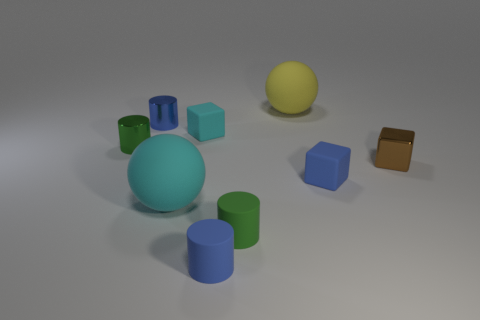Is the color of the matte sphere that is to the left of the large yellow object the same as the small rubber cube behind the small brown thing?
Your answer should be compact. Yes. There is a small thing that is both left of the blue rubber cylinder and on the right side of the tiny blue shiny cylinder; what is it made of?
Provide a succinct answer. Rubber. Is there a large shiny cylinder?
Ensure brevity in your answer.  No. The small cyan thing that is the same material as the small blue block is what shape?
Offer a very short reply. Cube. There is a blue metal thing; is its shape the same as the big matte object that is behind the cyan matte sphere?
Ensure brevity in your answer.  No. What material is the green cylinder behind the small block in front of the brown object?
Your answer should be compact. Metal. How many other things are there of the same shape as the brown object?
Give a very brief answer. 2. Is the shape of the shiny thing to the right of the green matte cylinder the same as the small blue thing that is to the left of the large cyan thing?
Give a very brief answer. No. Is there anything else that has the same material as the brown thing?
Provide a succinct answer. Yes. What is the tiny cyan cube made of?
Offer a very short reply. Rubber. 